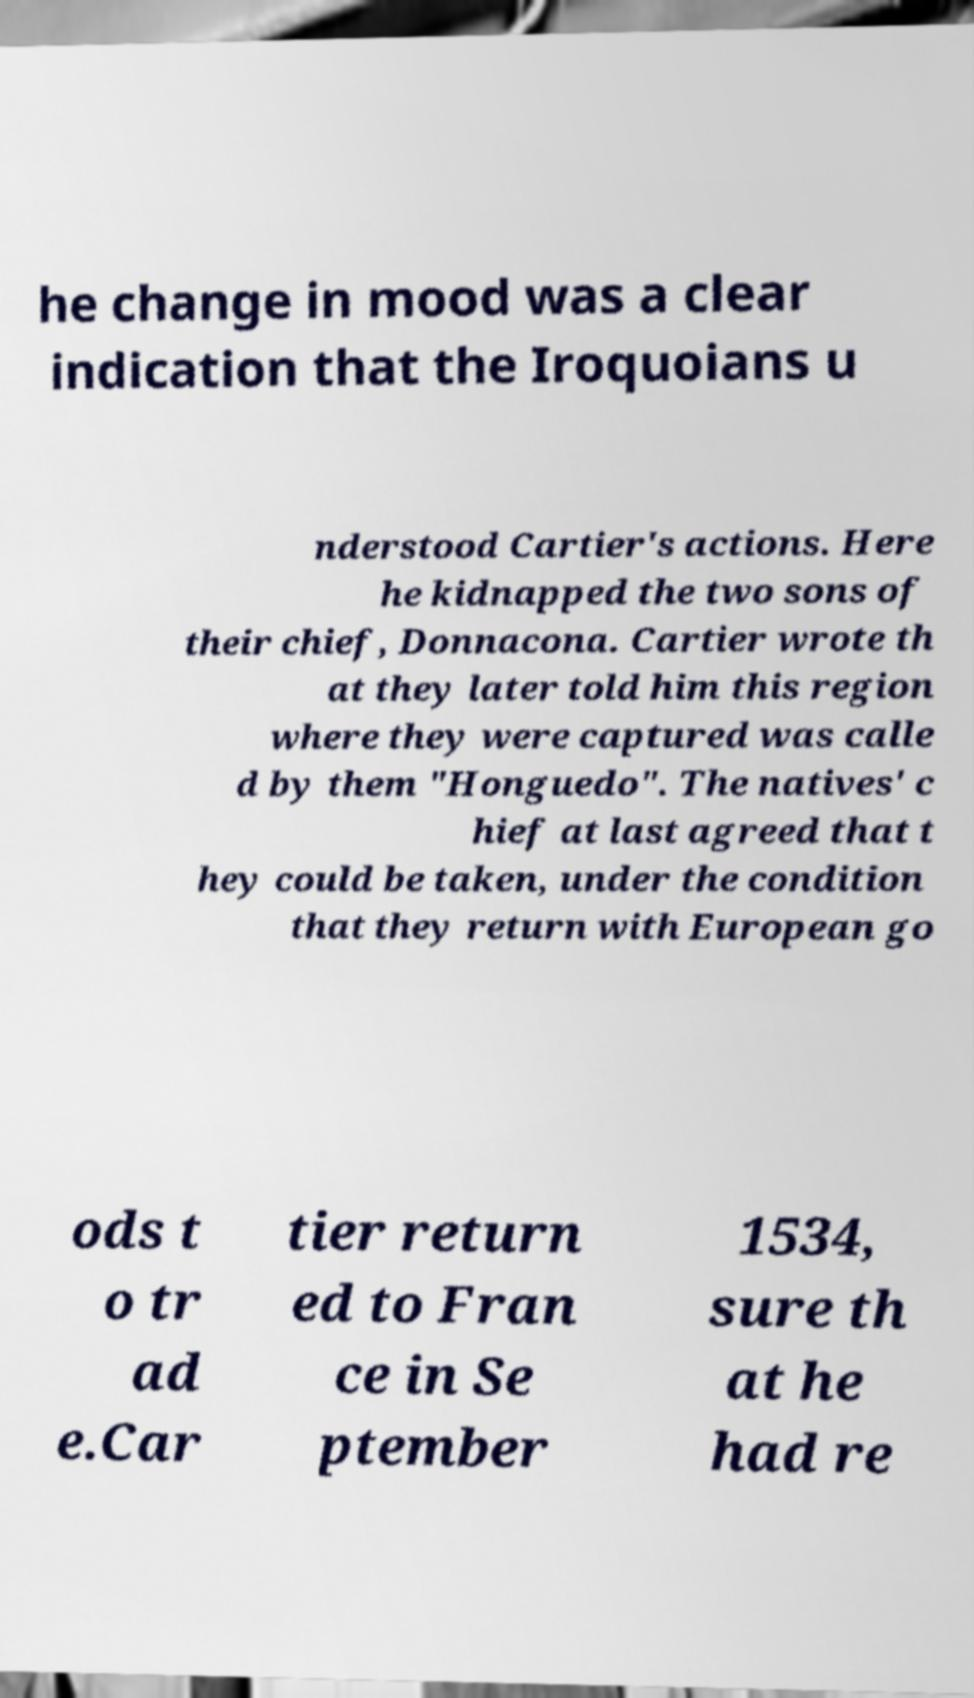Can you accurately transcribe the text from the provided image for me? he change in mood was a clear indication that the Iroquoians u nderstood Cartier's actions. Here he kidnapped the two sons of their chief, Donnacona. Cartier wrote th at they later told him this region where they were captured was calle d by them "Honguedo". The natives' c hief at last agreed that t hey could be taken, under the condition that they return with European go ods t o tr ad e.Car tier return ed to Fran ce in Se ptember 1534, sure th at he had re 